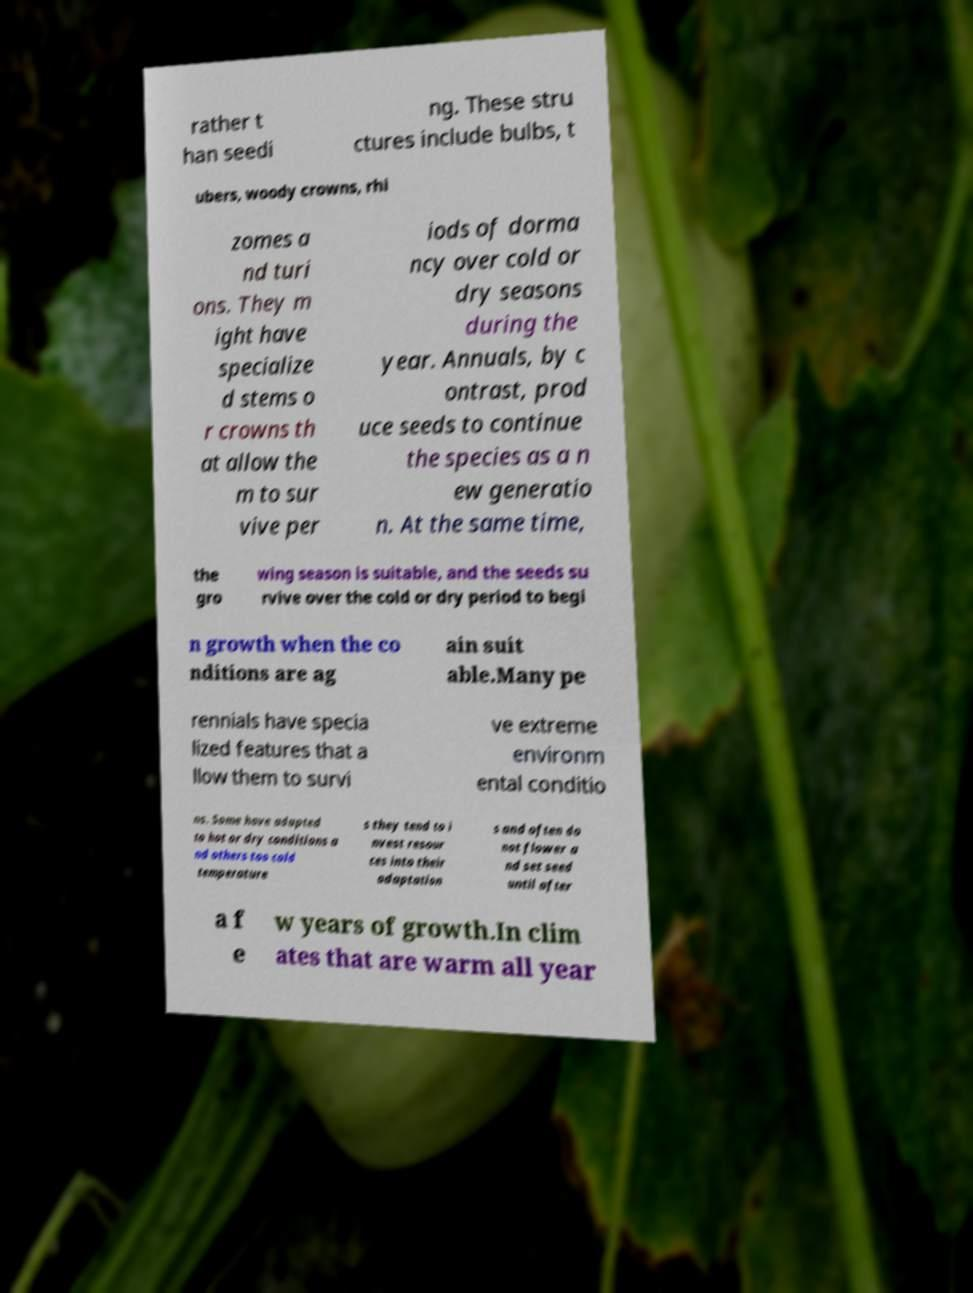What messages or text are displayed in this image? I need them in a readable, typed format. rather t han seedi ng. These stru ctures include bulbs, t ubers, woody crowns, rhi zomes a nd turi ons. They m ight have specialize d stems o r crowns th at allow the m to sur vive per iods of dorma ncy over cold or dry seasons during the year. Annuals, by c ontrast, prod uce seeds to continue the species as a n ew generatio n. At the same time, the gro wing season is suitable, and the seeds su rvive over the cold or dry period to begi n growth when the co nditions are ag ain suit able.Many pe rennials have specia lized features that a llow them to survi ve extreme environm ental conditio ns. Some have adapted to hot or dry conditions a nd others too cold temperature s they tend to i nvest resour ces into their adaptation s and often do not flower a nd set seed until after a f e w years of growth.In clim ates that are warm all year 